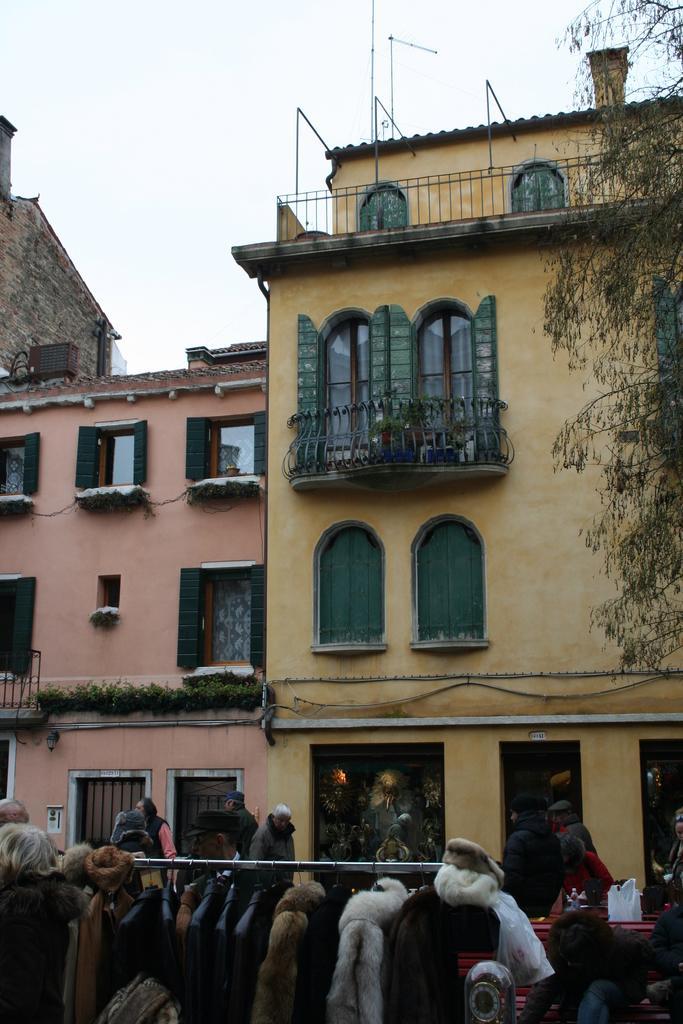In one or two sentences, can you explain what this image depicts? In this image few clothes are hanging to the metal rod. Right bottom few people are sitting on the bench. Few people are on the pavement. Right side there is a tree. Background there are buildings. Top of the image there is sky. 